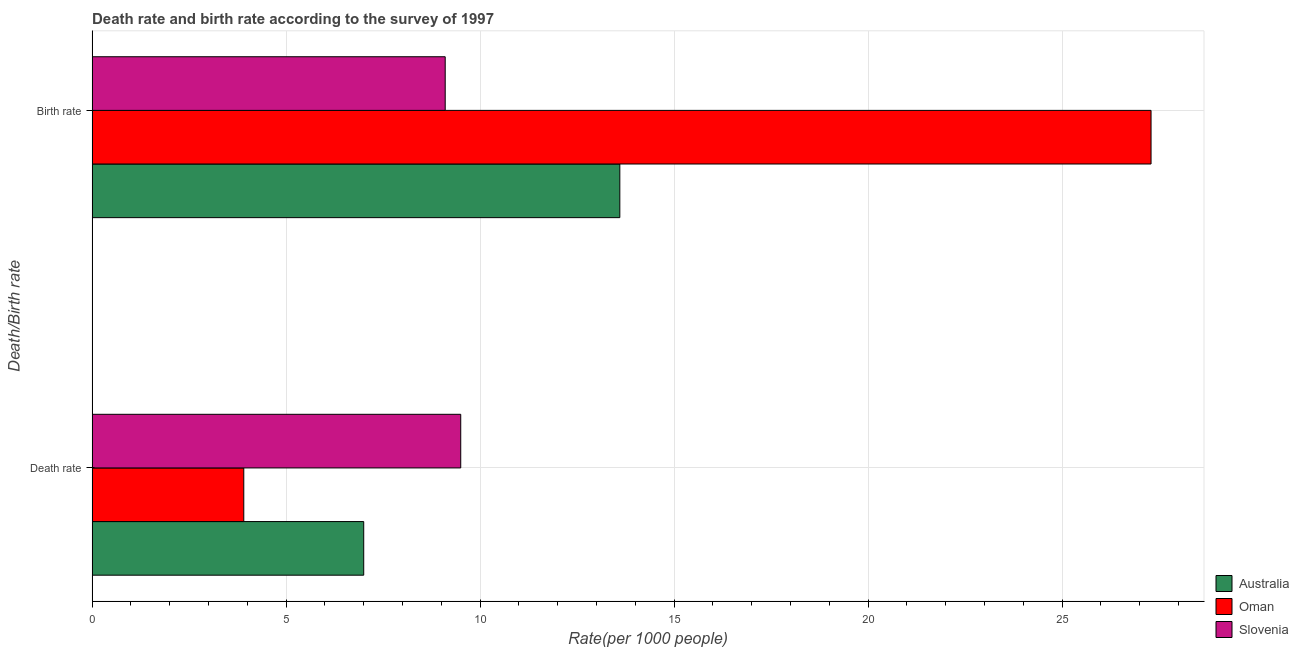How many different coloured bars are there?
Offer a terse response. 3. How many groups of bars are there?
Ensure brevity in your answer.  2. Are the number of bars on each tick of the Y-axis equal?
Provide a succinct answer. Yes. What is the label of the 1st group of bars from the top?
Provide a succinct answer. Birth rate. What is the death rate in Australia?
Keep it short and to the point. 7. Across all countries, what is the maximum death rate?
Offer a very short reply. 9.5. Across all countries, what is the minimum death rate?
Offer a very short reply. 3.91. In which country was the death rate maximum?
Keep it short and to the point. Slovenia. In which country was the birth rate minimum?
Your answer should be compact. Slovenia. What is the total birth rate in the graph?
Keep it short and to the point. 49.99. What is the difference between the birth rate in Slovenia and that in Oman?
Your answer should be very brief. -18.19. What is the difference between the death rate in Australia and the birth rate in Oman?
Your answer should be compact. -20.29. What is the average death rate per country?
Provide a short and direct response. 6.8. What is the difference between the birth rate and death rate in Australia?
Provide a short and direct response. 6.6. What is the ratio of the death rate in Australia to that in Oman?
Make the answer very short. 1.79. Is the death rate in Australia less than that in Oman?
Ensure brevity in your answer.  No. What does the 1st bar from the top in Birth rate represents?
Your response must be concise. Slovenia. What does the 3rd bar from the bottom in Death rate represents?
Provide a succinct answer. Slovenia. Are the values on the major ticks of X-axis written in scientific E-notation?
Keep it short and to the point. No. Does the graph contain any zero values?
Make the answer very short. No. Does the graph contain grids?
Provide a short and direct response. Yes. What is the title of the graph?
Keep it short and to the point. Death rate and birth rate according to the survey of 1997. What is the label or title of the X-axis?
Keep it short and to the point. Rate(per 1000 people). What is the label or title of the Y-axis?
Your response must be concise. Death/Birth rate. What is the Rate(per 1000 people) in Oman in Death rate?
Provide a succinct answer. 3.91. What is the Rate(per 1000 people) of Australia in Birth rate?
Offer a very short reply. 13.6. What is the Rate(per 1000 people) in Oman in Birth rate?
Make the answer very short. 27.29. What is the Rate(per 1000 people) of Slovenia in Birth rate?
Make the answer very short. 9.1. Across all Death/Birth rate, what is the maximum Rate(per 1000 people) of Oman?
Your answer should be very brief. 27.29. Across all Death/Birth rate, what is the minimum Rate(per 1000 people) in Oman?
Provide a short and direct response. 3.91. Across all Death/Birth rate, what is the minimum Rate(per 1000 people) in Slovenia?
Provide a succinct answer. 9.1. What is the total Rate(per 1000 people) of Australia in the graph?
Offer a very short reply. 20.6. What is the total Rate(per 1000 people) of Oman in the graph?
Make the answer very short. 31.2. What is the difference between the Rate(per 1000 people) in Oman in Death rate and that in Birth rate?
Provide a succinct answer. -23.38. What is the difference between the Rate(per 1000 people) of Slovenia in Death rate and that in Birth rate?
Make the answer very short. 0.4. What is the difference between the Rate(per 1000 people) in Australia in Death rate and the Rate(per 1000 people) in Oman in Birth rate?
Offer a terse response. -20.29. What is the difference between the Rate(per 1000 people) in Australia in Death rate and the Rate(per 1000 people) in Slovenia in Birth rate?
Make the answer very short. -2.1. What is the difference between the Rate(per 1000 people) in Oman in Death rate and the Rate(per 1000 people) in Slovenia in Birth rate?
Make the answer very short. -5.19. What is the average Rate(per 1000 people) of Oman per Death/Birth rate?
Your response must be concise. 15.6. What is the average Rate(per 1000 people) in Slovenia per Death/Birth rate?
Provide a succinct answer. 9.3. What is the difference between the Rate(per 1000 people) in Australia and Rate(per 1000 people) in Oman in Death rate?
Offer a terse response. 3.09. What is the difference between the Rate(per 1000 people) of Australia and Rate(per 1000 people) of Slovenia in Death rate?
Offer a terse response. -2.5. What is the difference between the Rate(per 1000 people) of Oman and Rate(per 1000 people) of Slovenia in Death rate?
Offer a terse response. -5.59. What is the difference between the Rate(per 1000 people) in Australia and Rate(per 1000 people) in Oman in Birth rate?
Your answer should be compact. -13.69. What is the difference between the Rate(per 1000 people) of Australia and Rate(per 1000 people) of Slovenia in Birth rate?
Provide a short and direct response. 4.5. What is the difference between the Rate(per 1000 people) of Oman and Rate(per 1000 people) of Slovenia in Birth rate?
Keep it short and to the point. 18.19. What is the ratio of the Rate(per 1000 people) of Australia in Death rate to that in Birth rate?
Offer a terse response. 0.51. What is the ratio of the Rate(per 1000 people) in Oman in Death rate to that in Birth rate?
Offer a very short reply. 0.14. What is the ratio of the Rate(per 1000 people) in Slovenia in Death rate to that in Birth rate?
Make the answer very short. 1.04. What is the difference between the highest and the second highest Rate(per 1000 people) of Australia?
Keep it short and to the point. 6.6. What is the difference between the highest and the second highest Rate(per 1000 people) in Oman?
Provide a succinct answer. 23.38. What is the difference between the highest and the lowest Rate(per 1000 people) in Oman?
Provide a short and direct response. 23.38. 